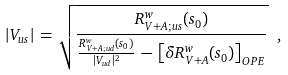Convert formula to latex. <formula><loc_0><loc_0><loc_500><loc_500>| V _ { u s } | \, = \, \sqrt { { \frac { R ^ { w } _ { V + A ; u s } ( s _ { 0 } ) } { { \frac { R ^ { w } _ { V + A ; u d } ( s _ { 0 } ) } { | V _ { u d } | ^ { 2 } } } \, - \, \left [ \delta R ^ { w } _ { V + A } ( s _ { 0 } ) \right ] _ { O P E } } } } \ ,</formula> 